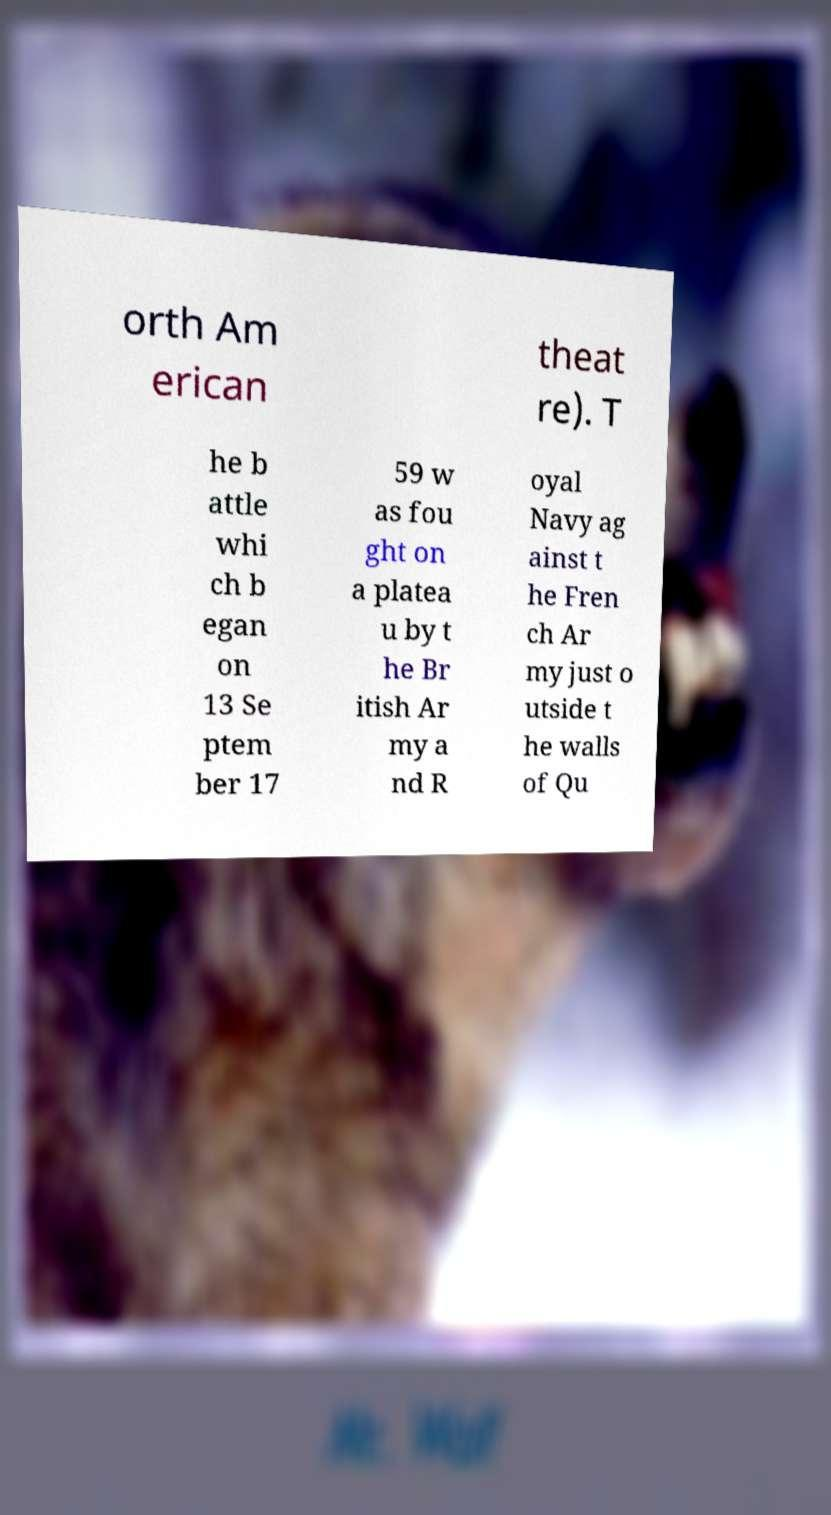There's text embedded in this image that I need extracted. Can you transcribe it verbatim? orth Am erican theat re). T he b attle whi ch b egan on 13 Se ptem ber 17 59 w as fou ght on a platea u by t he Br itish Ar my a nd R oyal Navy ag ainst t he Fren ch Ar my just o utside t he walls of Qu 